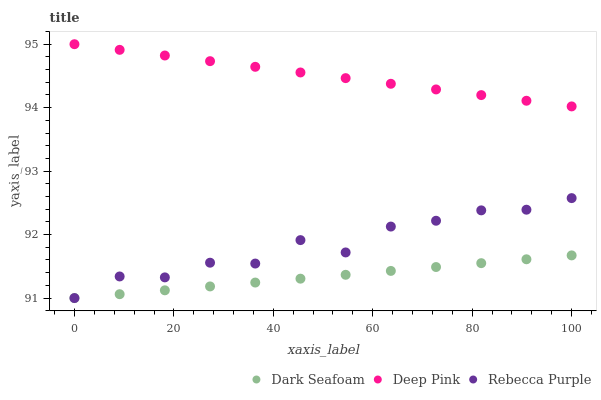Does Dark Seafoam have the minimum area under the curve?
Answer yes or no. Yes. Does Deep Pink have the maximum area under the curve?
Answer yes or no. Yes. Does Rebecca Purple have the minimum area under the curve?
Answer yes or no. No. Does Rebecca Purple have the maximum area under the curve?
Answer yes or no. No. Is Dark Seafoam the smoothest?
Answer yes or no. Yes. Is Rebecca Purple the roughest?
Answer yes or no. Yes. Is Deep Pink the smoothest?
Answer yes or no. No. Is Deep Pink the roughest?
Answer yes or no. No. Does Dark Seafoam have the lowest value?
Answer yes or no. Yes. Does Deep Pink have the lowest value?
Answer yes or no. No. Does Deep Pink have the highest value?
Answer yes or no. Yes. Does Rebecca Purple have the highest value?
Answer yes or no. No. Is Dark Seafoam less than Deep Pink?
Answer yes or no. Yes. Is Deep Pink greater than Dark Seafoam?
Answer yes or no. Yes. Does Rebecca Purple intersect Dark Seafoam?
Answer yes or no. Yes. Is Rebecca Purple less than Dark Seafoam?
Answer yes or no. No. Is Rebecca Purple greater than Dark Seafoam?
Answer yes or no. No. Does Dark Seafoam intersect Deep Pink?
Answer yes or no. No. 